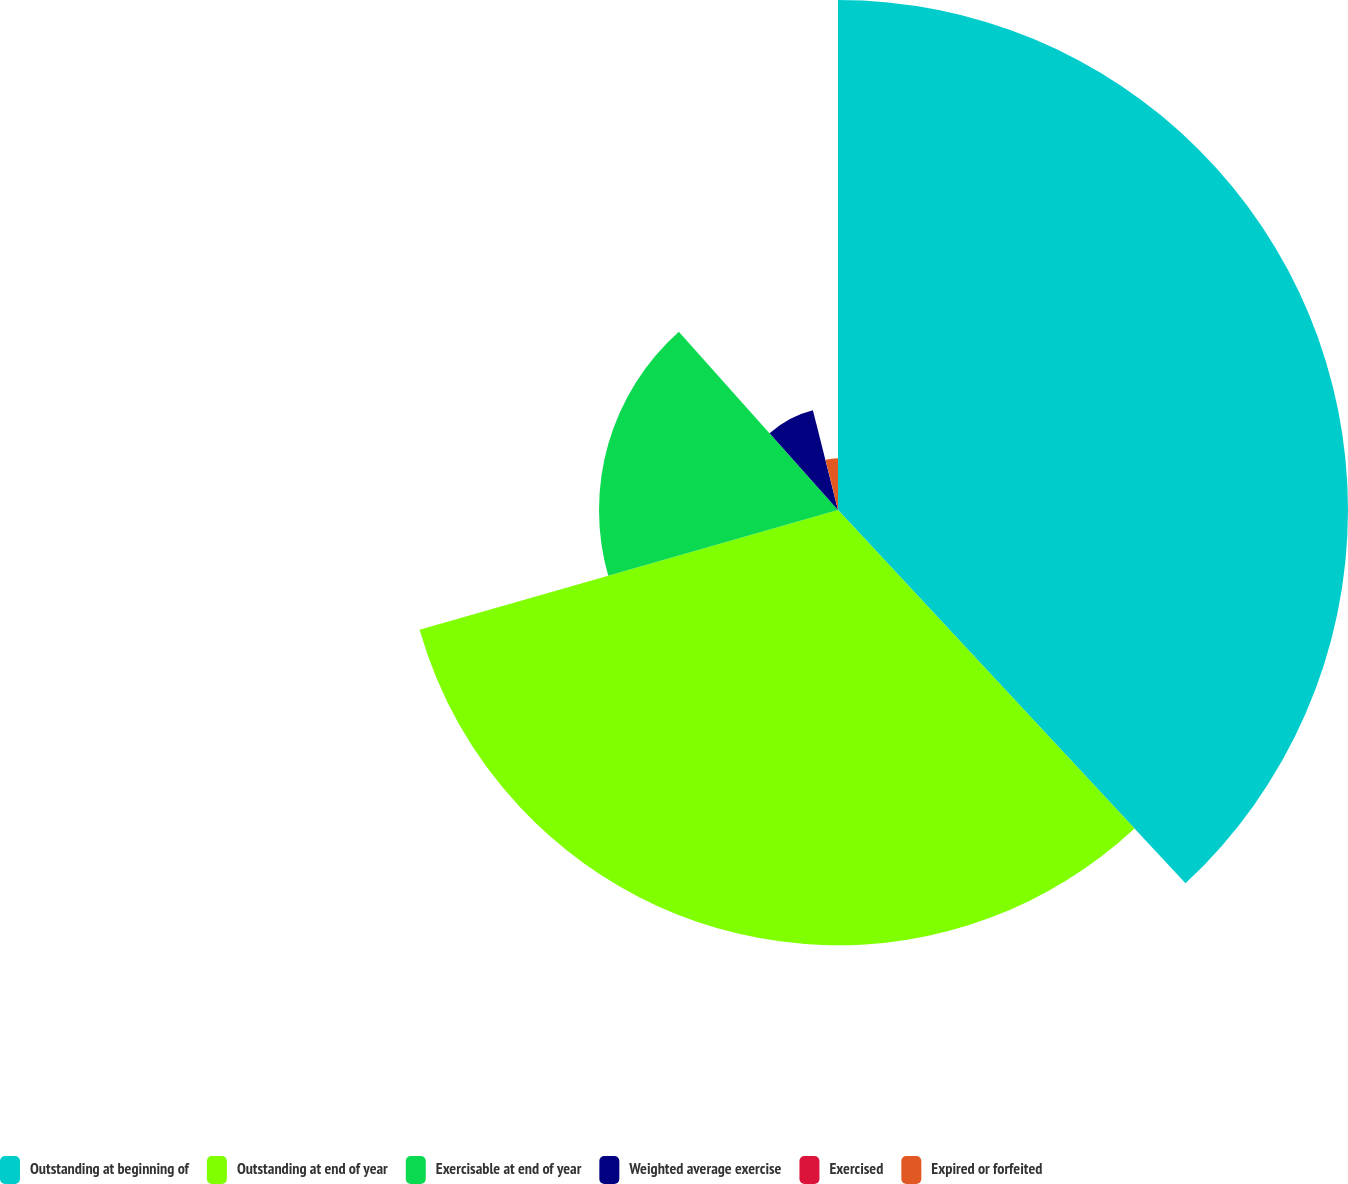Convert chart to OTSL. <chart><loc_0><loc_0><loc_500><loc_500><pie_chart><fcel>Outstanding at beginning of<fcel>Outstanding at end of year<fcel>Exercisable at end of year<fcel>Weighted average exercise<fcel>Exercised<fcel>Expired or forfeited<nl><fcel>38.07%<fcel>32.49%<fcel>17.84%<fcel>7.67%<fcel>0.06%<fcel>3.87%<nl></chart> 